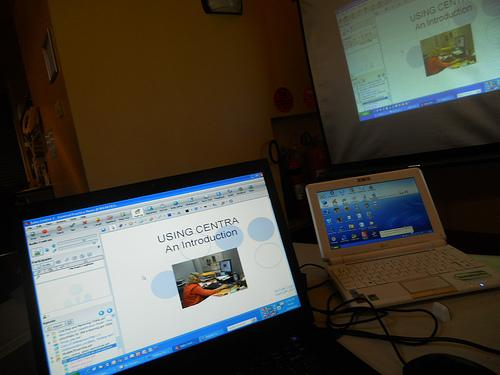In a casual tone, narrate what you see in the image. So there are these two laptops, one white and the other black, chilling on a table with a keyboard and a mouse. There's also a projector screen showing some presentation, and a random red fire extinguisher. What are the electronic devices present in the image, and what are some activities that can be seen on the screen? Electronic devices - white laptop, black laptop, keyboard, computer mouse, and wall phone. Activities on the screen - email client open, desktop background with icons, and presentation projected. Mention some objects related to technology and communication in the image. Small white laptop, black laptop with a computer program open, keyboard, black computer mouse, and an off-white wall phone are related to technology and communication. Describe the position and appearance of the laptops in the image. One white laptop is sitting on a table with a small screen and keyboard, while the black laptop nearby has a larger screen with a website displayed and a computer program open. Provide a brief overview of the most important elements in the image. A small white laptop on a table, a black laptop with a program open, a presentation on a screen, black cables and a red fire extinguisher are present in the image. Explain what kind of workspace is depicted in the image. The image shows a workspace with two laptops, a keyboard, a mouse, a table, and a presentation being projected onto a screen, suggesting a tech-oriented or office environment. Mention the key objects in the image and how they are related. Two laptops sit on a white table next to a keyboard and black computer mouse, with black cables nearby; a presentation is displayed on a large projected screen on the wall. Describe some of the interesting details that you notice in the image. A white small laptop has a black tangled cable on it; there's a white table with black electric cords, and a red sticker on the wall adds a dash of color to the scene. Identify the furniture and decoration items in the image, including their color. In the image, there is a white table, a white pull-down projector screen, a white picture hanging on the wall, and a red sticker on the wall. List down three main objects and three minor objects that can be seen in the image. Minor objects: red fire extinguisher, light switch, white picture on the wall. 